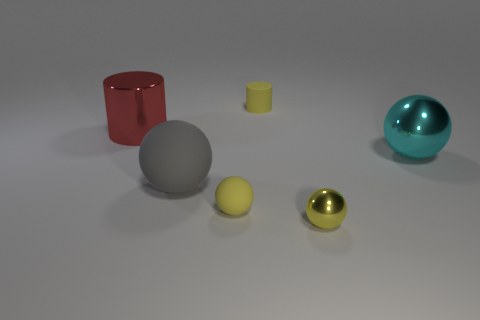What is the color of the metal object that is both behind the yellow matte ball and on the left side of the cyan object?
Your answer should be very brief. Red. Is the number of gray spheres that are to the left of the large cylinder greater than the number of tiny yellow cylinders in front of the gray rubber object?
Your answer should be compact. No. There is a gray thing that is the same material as the small cylinder; what is its size?
Keep it short and to the point. Large. How many metallic objects are to the left of the big sphere that is on the right side of the big gray ball?
Your answer should be compact. 2. Is there a big matte thing that has the same shape as the large cyan metallic object?
Provide a short and direct response. Yes. What color is the small rubber thing on the left side of the tiny matte thing behind the large cylinder?
Keep it short and to the point. Yellow. Is the number of large green matte cubes greater than the number of tiny metal spheres?
Offer a very short reply. No. What number of other objects have the same size as the red thing?
Give a very brief answer. 2. Are the cyan thing and the yellow thing left of the yellow matte cylinder made of the same material?
Your answer should be very brief. No. Are there fewer rubber balls than big red metallic cubes?
Offer a terse response. No. 